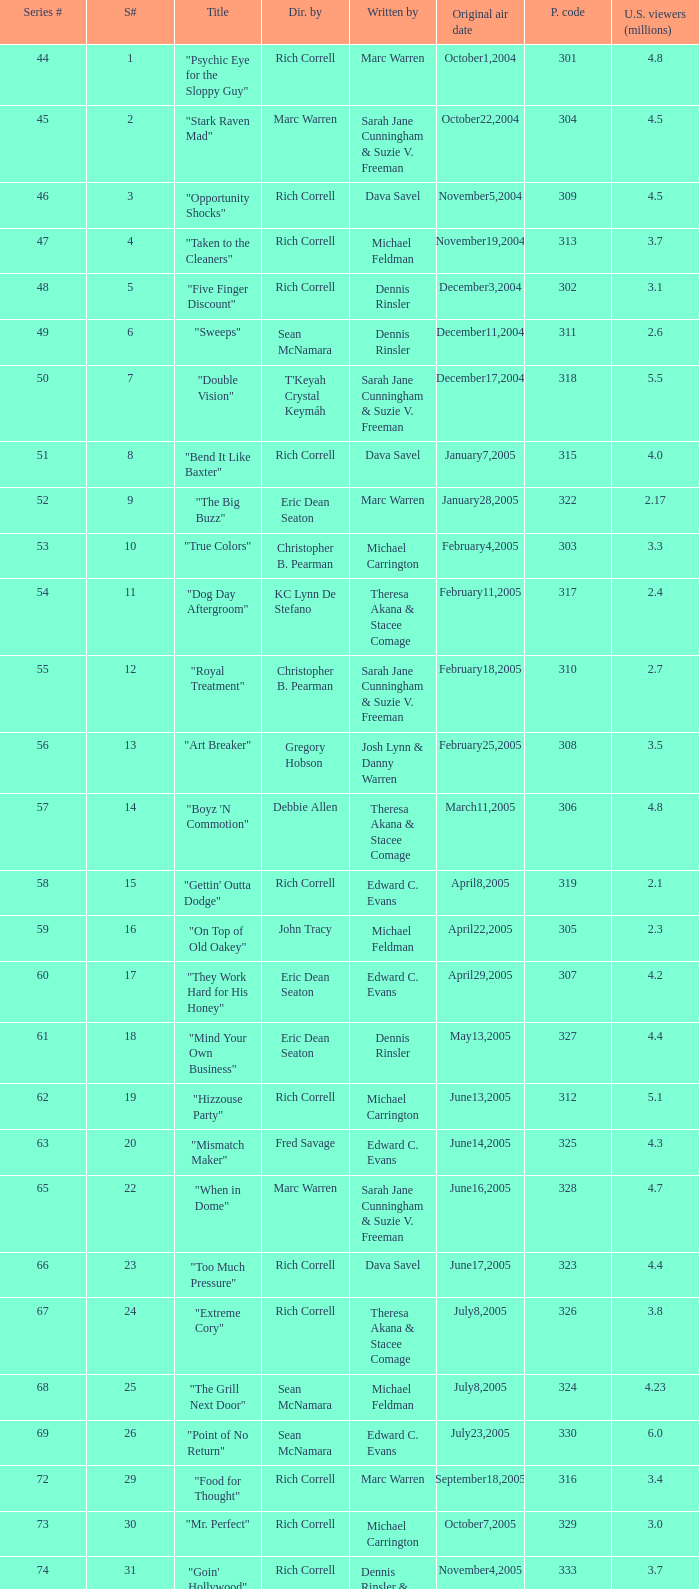What number episode of the season was titled "Vision Impossible"? 34.0. 